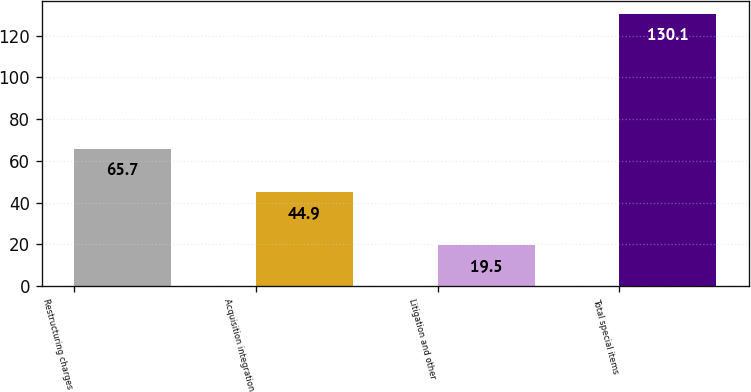Convert chart to OTSL. <chart><loc_0><loc_0><loc_500><loc_500><bar_chart><fcel>Restructuring charges<fcel>Acquisition integration<fcel>Litigation and other<fcel>Total special items<nl><fcel>65.7<fcel>44.9<fcel>19.5<fcel>130.1<nl></chart> 